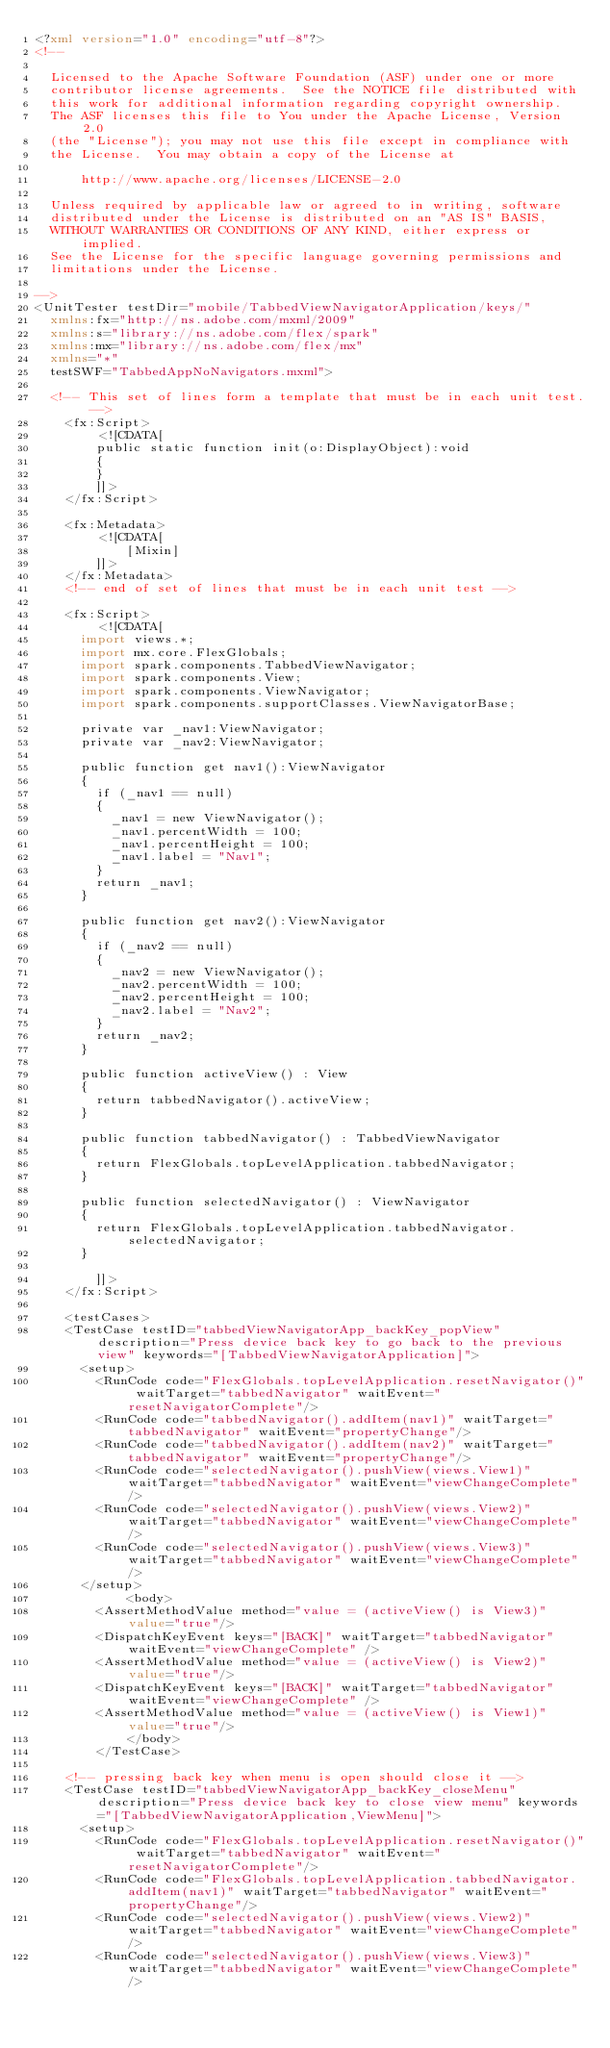<code> <loc_0><loc_0><loc_500><loc_500><_XML_><?xml version="1.0" encoding="utf-8"?>
<!--

  Licensed to the Apache Software Foundation (ASF) under one or more
  contributor license agreements.  See the NOTICE file distributed with
  this work for additional information regarding copyright ownership.
  The ASF licenses this file to You under the Apache License, Version 2.0
  (the "License"); you may not use this file except in compliance with
  the License.  You may obtain a copy of the License at

      http://www.apache.org/licenses/LICENSE-2.0

  Unless required by applicable law or agreed to in writing, software
  distributed under the License is distributed on an "AS IS" BASIS,
  WITHOUT WARRANTIES OR CONDITIONS OF ANY KIND, either express or implied.
  See the License for the specific language governing permissions and
  limitations under the License.

-->
<UnitTester testDir="mobile/TabbedViewNavigatorApplication/keys/"  
	xmlns:fx="http://ns.adobe.com/mxml/2009" 
	xmlns:s="library://ns.adobe.com/flex/spark" 
	xmlns:mx="library://ns.adobe.com/flex/mx"
	xmlns="*" 
	testSWF="TabbedAppNoNavigators.mxml">
    
	<!-- This set of lines form a template that must be in each unit test. -->
    <fx:Script>
        <![CDATA[
        public static function init(o:DisplayObject):void
        {
        }           
        ]]>
    </fx:Script>
    
    <fx:Metadata>
        <![CDATA[
            [Mixin]
        ]]>
    </fx:Metadata>  
    <!-- end of set of lines that must be in each unit test -->

    <fx:Script>
        <![CDATA[
			import views.*;
			import mx.core.FlexGlobals;
			import spark.components.TabbedViewNavigator;
			import spark.components.View;
			import spark.components.ViewNavigator;
			import spark.components.supportClasses.ViewNavigatorBase;

			private var _nav1:ViewNavigator;
			private var _nav2:ViewNavigator;
			
			public function get nav1():ViewNavigator
			{
				if (_nav1 == null)
				{
					_nav1 = new ViewNavigator();
					_nav1.percentWidth = 100;
					_nav1.percentHeight = 100;
					_nav1.label = "Nav1";
				}
				return _nav1;
			}

			public function get nav2():ViewNavigator
			{
				if (_nav2 == null)
				{
					_nav2 = new ViewNavigator();
					_nav2.percentWidth = 100;
					_nav2.percentHeight = 100;
					_nav2.label = "Nav2";
				}
				return _nav2;
			}
			
			public function activeView() : View 
			{
				return tabbedNavigator().activeView;
			}

			public function tabbedNavigator() : TabbedViewNavigator 
			{
				return FlexGlobals.topLevelApplication.tabbedNavigator;
			}
			
			public function selectedNavigator() : ViewNavigator 
			{
				return FlexGlobals.topLevelApplication.tabbedNavigator.selectedNavigator;
			}
			
        ]]>
    </fx:Script>

    <testCases>
		<TestCase testID="tabbedViewNavigatorApp_backKey_popView" description="Press device back key to go back to the previous view" keywords="[TabbedViewNavigatorApplication]">
			<setup>
				<RunCode code="FlexGlobals.topLevelApplication.resetNavigator()" waitTarget="tabbedNavigator" waitEvent="resetNavigatorComplete"/>
				<RunCode code="tabbedNavigator().addItem(nav1)" waitTarget="tabbedNavigator" waitEvent="propertyChange"/>				
				<RunCode code="tabbedNavigator().addItem(nav2)" waitTarget="tabbedNavigator" waitEvent="propertyChange"/>				
				<RunCode code="selectedNavigator().pushView(views.View1)" waitTarget="tabbedNavigator" waitEvent="viewChangeComplete"/>
				<RunCode code="selectedNavigator().pushView(views.View2)" waitTarget="tabbedNavigator" waitEvent="viewChangeComplete"/>
				<RunCode code="selectedNavigator().pushView(views.View3)" waitTarget="tabbedNavigator" waitEvent="viewChangeComplete"/>							
			</setup>
            <body>
				<AssertMethodValue method="value = (activeView() is View3)" value="true"/>
				<DispatchKeyEvent keys="[BACK]" waitTarget="tabbedNavigator" waitEvent="viewChangeComplete" />
				<AssertMethodValue method="value = (activeView() is View2)" value="true"/>
				<DispatchKeyEvent keys="[BACK]" waitTarget="tabbedNavigator" waitEvent="viewChangeComplete" />
				<AssertMethodValue method="value = (activeView() is View1)" value="true"/>
            </body>
        </TestCase>

		<!-- pressing back key when menu is open should close it -->
		<TestCase testID="tabbedViewNavigatorApp_backKey_closeMenu" description="Press device back key to close view menu" keywords="[TabbedViewNavigatorApplication,ViewMenu]">
			<setup>
				<RunCode code="FlexGlobals.topLevelApplication.resetNavigator()" waitTarget="tabbedNavigator" waitEvent="resetNavigatorComplete"/>
				<RunCode code="FlexGlobals.topLevelApplication.tabbedNavigator.addItem(nav1)" waitTarget="tabbedNavigator" waitEvent="propertyChange"/>				
				<RunCode code="selectedNavigator().pushView(views.View2)" waitTarget="tabbedNavigator" waitEvent="viewChangeComplete"/>
				<RunCode code="selectedNavigator().pushView(views.View3)" waitTarget="tabbedNavigator" waitEvent="viewChangeComplete"/></code> 